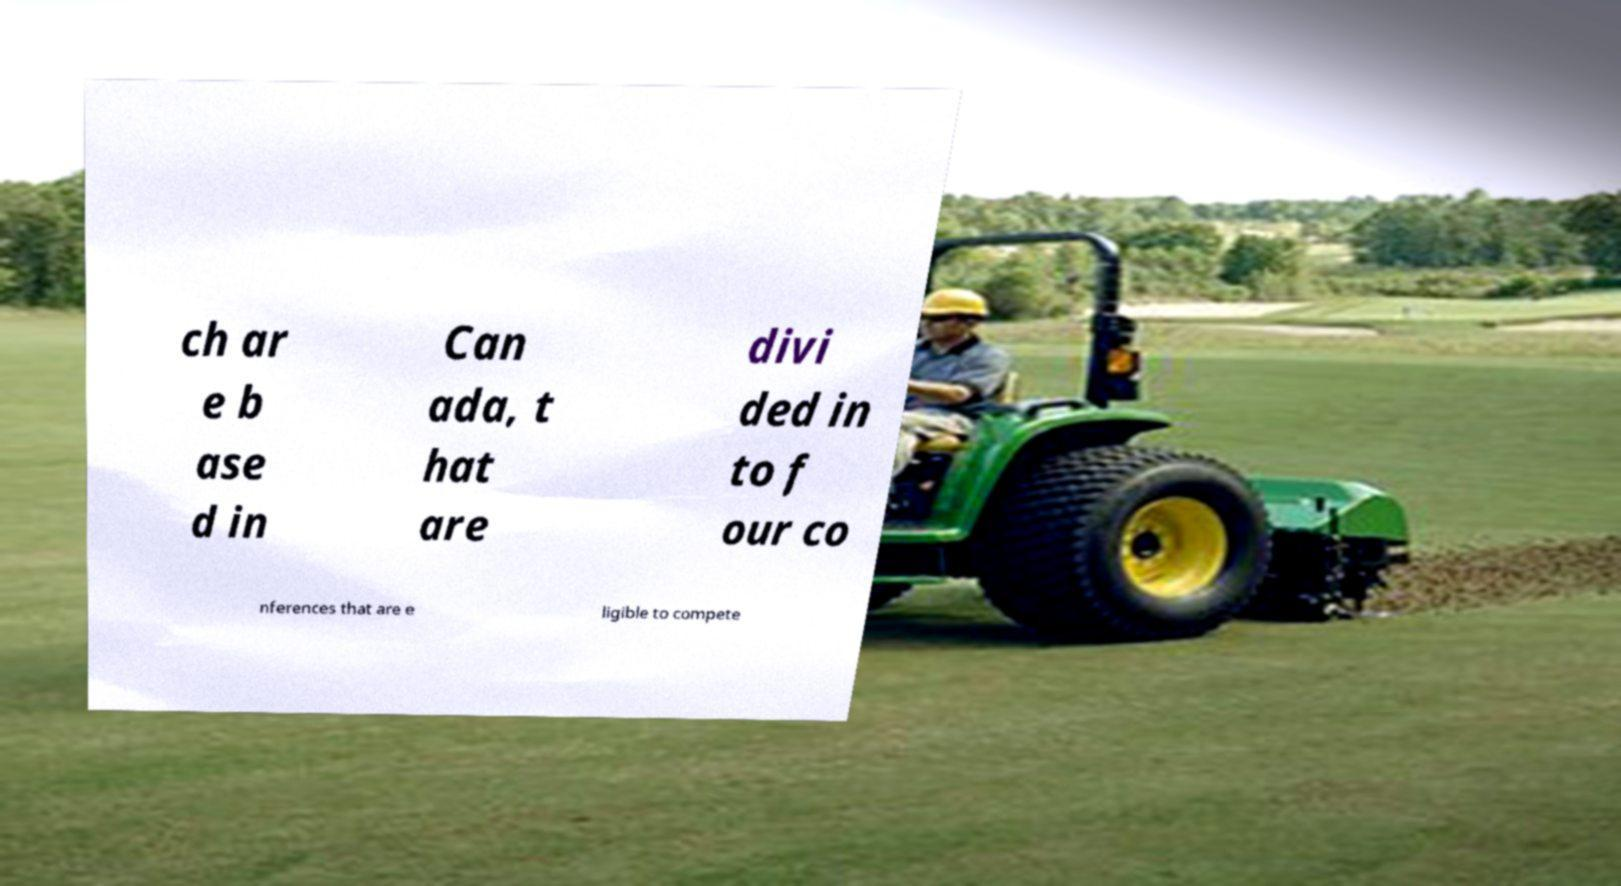Can you read and provide the text displayed in the image?This photo seems to have some interesting text. Can you extract and type it out for me? ch ar e b ase d in Can ada, t hat are divi ded in to f our co nferences that are e ligible to compete 